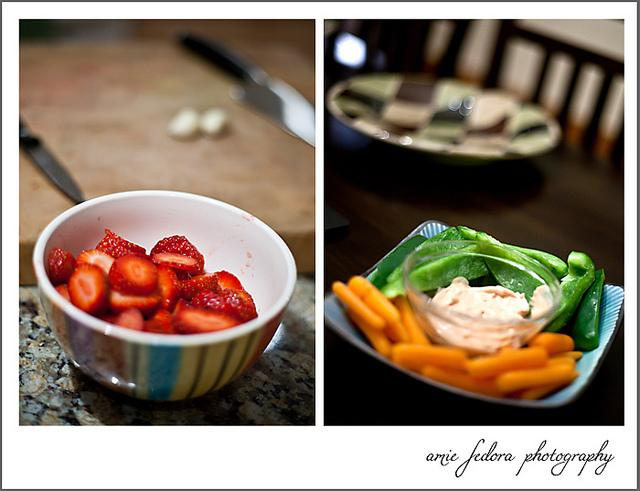What is in the bowl on the left?

Choices:
A) strawberries
B) lemons
C) grapes
D) apples strawberries 